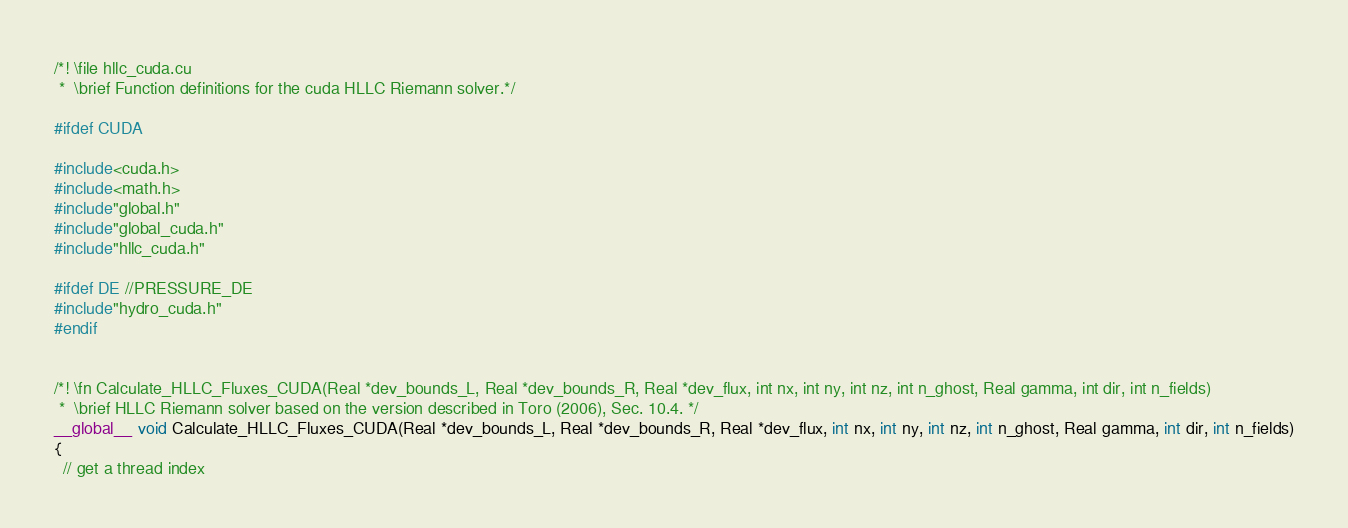Convert code to text. <code><loc_0><loc_0><loc_500><loc_500><_Cuda_>/*! \file hllc_cuda.cu
 *  \brief Function definitions for the cuda HLLC Riemann solver.*/

#ifdef CUDA

#include<cuda.h>
#include<math.h>
#include"global.h"
#include"global_cuda.h"
#include"hllc_cuda.h"

#ifdef DE //PRESSURE_DE
#include"hydro_cuda.h"
#endif


/*! \fn Calculate_HLLC_Fluxes_CUDA(Real *dev_bounds_L, Real *dev_bounds_R, Real *dev_flux, int nx, int ny, int nz, int n_ghost, Real gamma, int dir, int n_fields)
 *  \brief HLLC Riemann solver based on the version described in Toro (2006), Sec. 10.4. */
__global__ void Calculate_HLLC_Fluxes_CUDA(Real *dev_bounds_L, Real *dev_bounds_R, Real *dev_flux, int nx, int ny, int nz, int n_ghost, Real gamma, int dir, int n_fields)
{
  // get a thread index</code> 